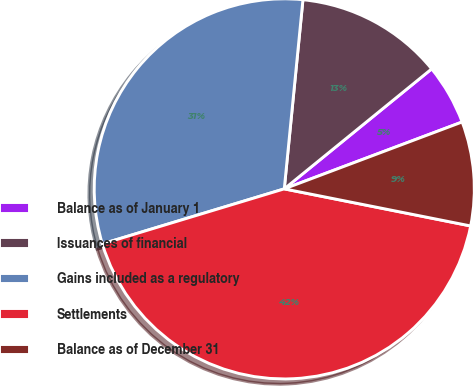Convert chart. <chart><loc_0><loc_0><loc_500><loc_500><pie_chart><fcel>Balance as of January 1<fcel>Issuances of financial<fcel>Gains included as a regulatory<fcel>Settlements<fcel>Balance as of December 31<nl><fcel>5.15%<fcel>12.56%<fcel>31.24%<fcel>42.2%<fcel>8.85%<nl></chart> 